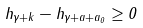Convert formula to latex. <formula><loc_0><loc_0><loc_500><loc_500>h _ { \gamma + k } - h _ { \gamma + a + a _ { 0 } } \geq 0</formula> 